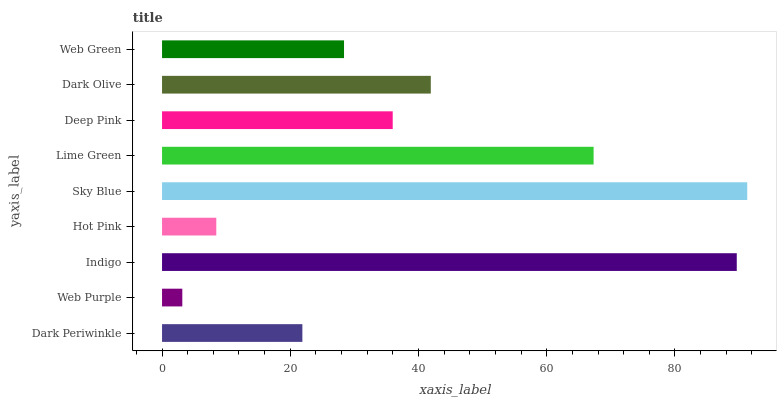Is Web Purple the minimum?
Answer yes or no. Yes. Is Sky Blue the maximum?
Answer yes or no. Yes. Is Indigo the minimum?
Answer yes or no. No. Is Indigo the maximum?
Answer yes or no. No. Is Indigo greater than Web Purple?
Answer yes or no. Yes. Is Web Purple less than Indigo?
Answer yes or no. Yes. Is Web Purple greater than Indigo?
Answer yes or no. No. Is Indigo less than Web Purple?
Answer yes or no. No. Is Deep Pink the high median?
Answer yes or no. Yes. Is Deep Pink the low median?
Answer yes or no. Yes. Is Web Green the high median?
Answer yes or no. No. Is Indigo the low median?
Answer yes or no. No. 